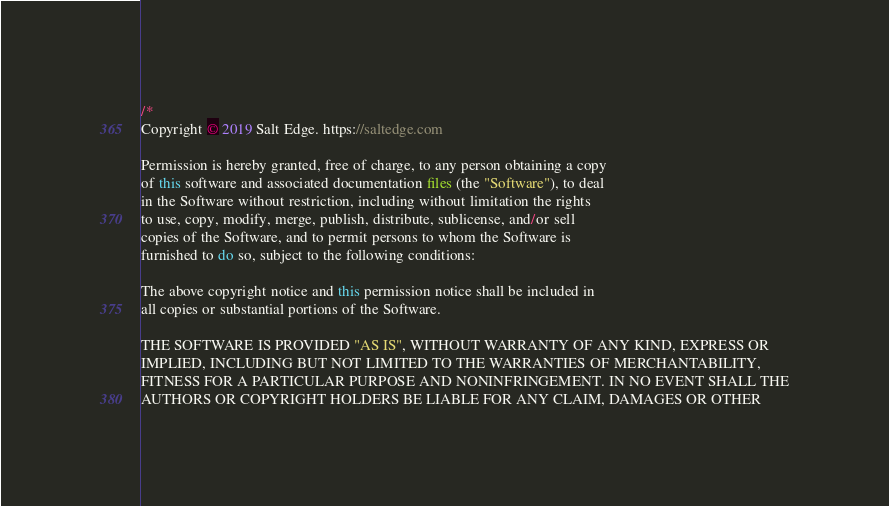<code> <loc_0><loc_0><loc_500><loc_500><_Java_>/*
Copyright © 2019 Salt Edge. https://saltedge.com

Permission is hereby granted, free of charge, to any person obtaining a copy
of this software and associated documentation files (the "Software"), to deal
in the Software without restriction, including without limitation the rights
to use, copy, modify, merge, publish, distribute, sublicense, and/or sell
copies of the Software, and to permit persons to whom the Software is
furnished to do so, subject to the following conditions:

The above copyright notice and this permission notice shall be included in
all copies or substantial portions of the Software.

THE SOFTWARE IS PROVIDED "AS IS", WITHOUT WARRANTY OF ANY KIND, EXPRESS OR
IMPLIED, INCLUDING BUT NOT LIMITED TO THE WARRANTIES OF MERCHANTABILITY,
FITNESS FOR A PARTICULAR PURPOSE AND NONINFRINGEMENT. IN NO EVENT SHALL THE
AUTHORS OR COPYRIGHT HOLDERS BE LIABLE FOR ANY CLAIM, DAMAGES OR OTHER</code> 